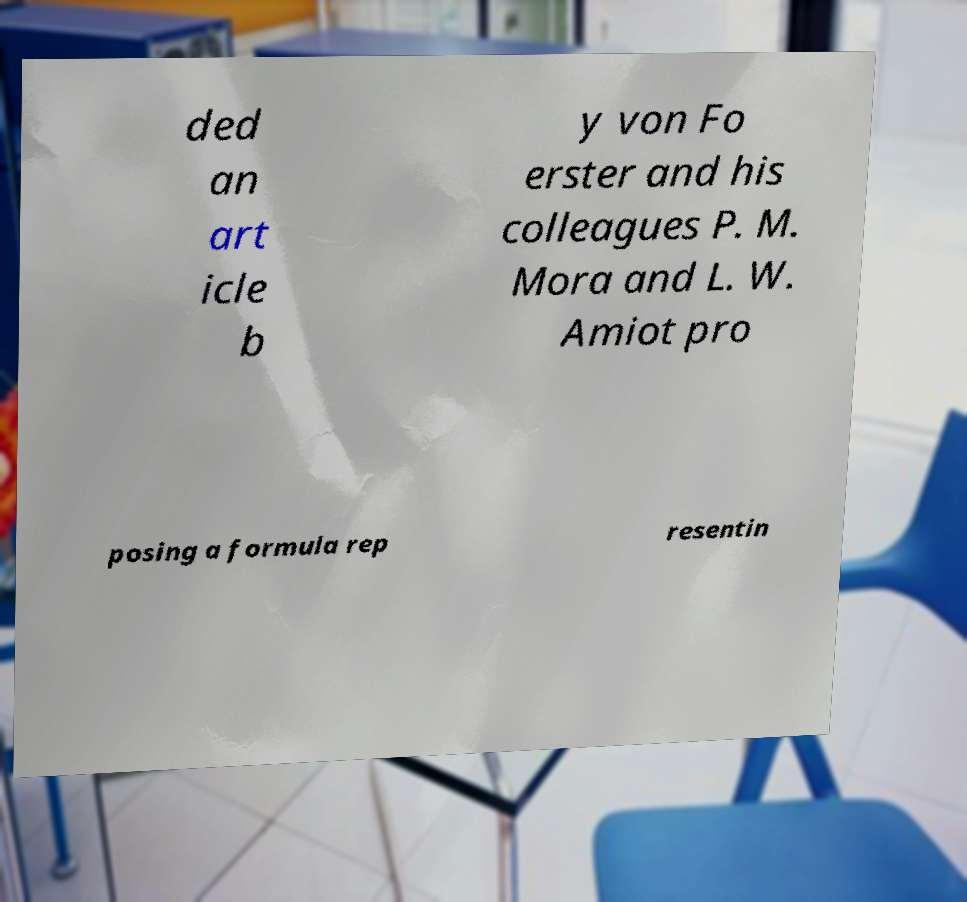I need the written content from this picture converted into text. Can you do that? ded an art icle b y von Fo erster and his colleagues P. M. Mora and L. W. Amiot pro posing a formula rep resentin 